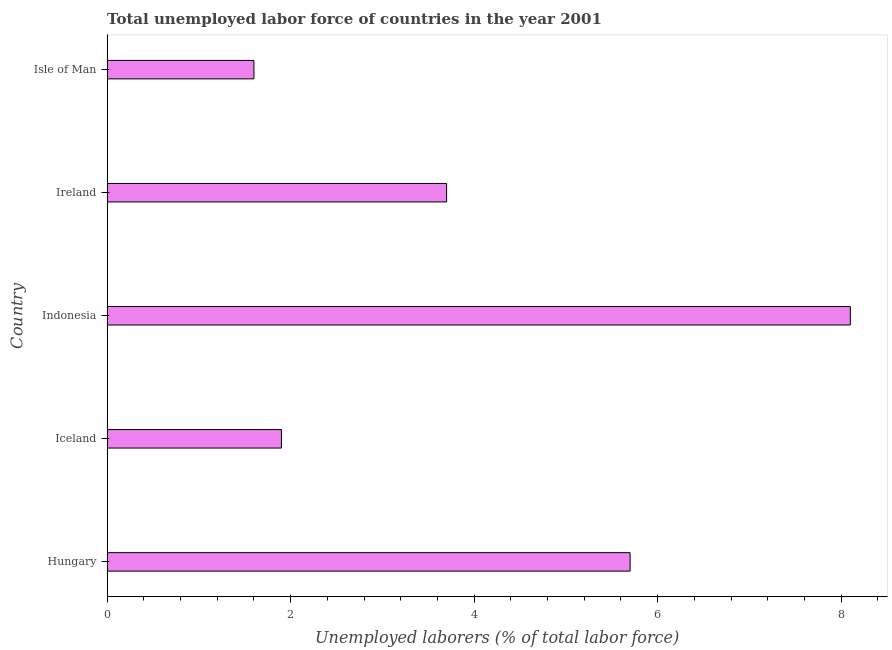Does the graph contain any zero values?
Offer a very short reply. No. Does the graph contain grids?
Provide a succinct answer. No. What is the title of the graph?
Give a very brief answer. Total unemployed labor force of countries in the year 2001. What is the label or title of the X-axis?
Provide a succinct answer. Unemployed laborers (% of total labor force). What is the label or title of the Y-axis?
Give a very brief answer. Country. What is the total unemployed labour force in Ireland?
Your answer should be very brief. 3.7. Across all countries, what is the maximum total unemployed labour force?
Your answer should be very brief. 8.1. Across all countries, what is the minimum total unemployed labour force?
Offer a terse response. 1.6. In which country was the total unemployed labour force minimum?
Keep it short and to the point. Isle of Man. What is the sum of the total unemployed labour force?
Offer a very short reply. 21. What is the difference between the total unemployed labour force in Ireland and Isle of Man?
Provide a succinct answer. 2.1. What is the median total unemployed labour force?
Provide a short and direct response. 3.7. In how many countries, is the total unemployed labour force greater than 4 %?
Your answer should be compact. 2. What is the ratio of the total unemployed labour force in Iceland to that in Ireland?
Ensure brevity in your answer.  0.51. Is the difference between the total unemployed labour force in Hungary and Indonesia greater than the difference between any two countries?
Your response must be concise. No. What is the difference between the highest and the second highest total unemployed labour force?
Your answer should be compact. 2.4. Is the sum of the total unemployed labour force in Hungary and Ireland greater than the maximum total unemployed labour force across all countries?
Your answer should be very brief. Yes. What is the difference between the highest and the lowest total unemployed labour force?
Offer a terse response. 6.5. How many bars are there?
Offer a very short reply. 5. How many countries are there in the graph?
Ensure brevity in your answer.  5. Are the values on the major ticks of X-axis written in scientific E-notation?
Keep it short and to the point. No. What is the Unemployed laborers (% of total labor force) in Hungary?
Give a very brief answer. 5.7. What is the Unemployed laborers (% of total labor force) of Iceland?
Provide a short and direct response. 1.9. What is the Unemployed laborers (% of total labor force) of Indonesia?
Your answer should be compact. 8.1. What is the Unemployed laborers (% of total labor force) in Ireland?
Your answer should be very brief. 3.7. What is the Unemployed laborers (% of total labor force) in Isle of Man?
Offer a terse response. 1.6. What is the difference between the Unemployed laborers (% of total labor force) in Hungary and Iceland?
Provide a succinct answer. 3.8. What is the difference between the Unemployed laborers (% of total labor force) in Hungary and Indonesia?
Your answer should be very brief. -2.4. What is the difference between the Unemployed laborers (% of total labor force) in Hungary and Ireland?
Offer a very short reply. 2. What is the difference between the Unemployed laborers (% of total labor force) in Hungary and Isle of Man?
Provide a succinct answer. 4.1. What is the difference between the Unemployed laborers (% of total labor force) in Iceland and Indonesia?
Your response must be concise. -6.2. What is the difference between the Unemployed laborers (% of total labor force) in Iceland and Ireland?
Offer a terse response. -1.8. What is the difference between the Unemployed laborers (% of total labor force) in Indonesia and Ireland?
Provide a succinct answer. 4.4. What is the difference between the Unemployed laborers (% of total labor force) in Indonesia and Isle of Man?
Keep it short and to the point. 6.5. What is the difference between the Unemployed laborers (% of total labor force) in Ireland and Isle of Man?
Keep it short and to the point. 2.1. What is the ratio of the Unemployed laborers (% of total labor force) in Hungary to that in Iceland?
Your answer should be compact. 3. What is the ratio of the Unemployed laborers (% of total labor force) in Hungary to that in Indonesia?
Provide a short and direct response. 0.7. What is the ratio of the Unemployed laborers (% of total labor force) in Hungary to that in Ireland?
Give a very brief answer. 1.54. What is the ratio of the Unemployed laborers (% of total labor force) in Hungary to that in Isle of Man?
Keep it short and to the point. 3.56. What is the ratio of the Unemployed laborers (% of total labor force) in Iceland to that in Indonesia?
Ensure brevity in your answer.  0.23. What is the ratio of the Unemployed laborers (% of total labor force) in Iceland to that in Ireland?
Provide a succinct answer. 0.51. What is the ratio of the Unemployed laborers (% of total labor force) in Iceland to that in Isle of Man?
Offer a terse response. 1.19. What is the ratio of the Unemployed laborers (% of total labor force) in Indonesia to that in Ireland?
Ensure brevity in your answer.  2.19. What is the ratio of the Unemployed laborers (% of total labor force) in Indonesia to that in Isle of Man?
Provide a succinct answer. 5.06. What is the ratio of the Unemployed laborers (% of total labor force) in Ireland to that in Isle of Man?
Your response must be concise. 2.31. 